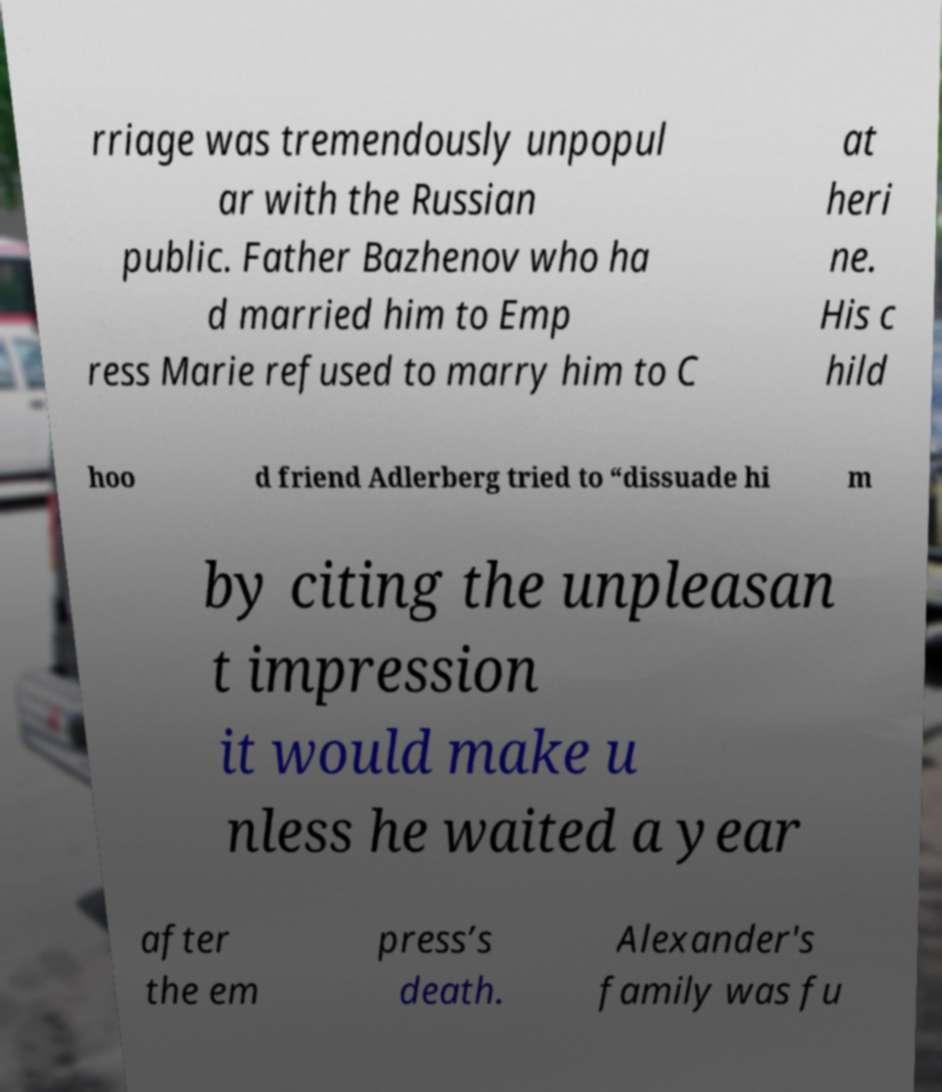Can you accurately transcribe the text from the provided image for me? rriage was tremendously unpopul ar with the Russian public. Father Bazhenov who ha d married him to Emp ress Marie refused to marry him to C at heri ne. His c hild hoo d friend Adlerberg tried to “dissuade hi m by citing the unpleasan t impression it would make u nless he waited a year after the em press’s death. Alexander's family was fu 